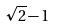Convert formula to latex. <formula><loc_0><loc_0><loc_500><loc_500>\sqrt { 2 } - 1</formula> 